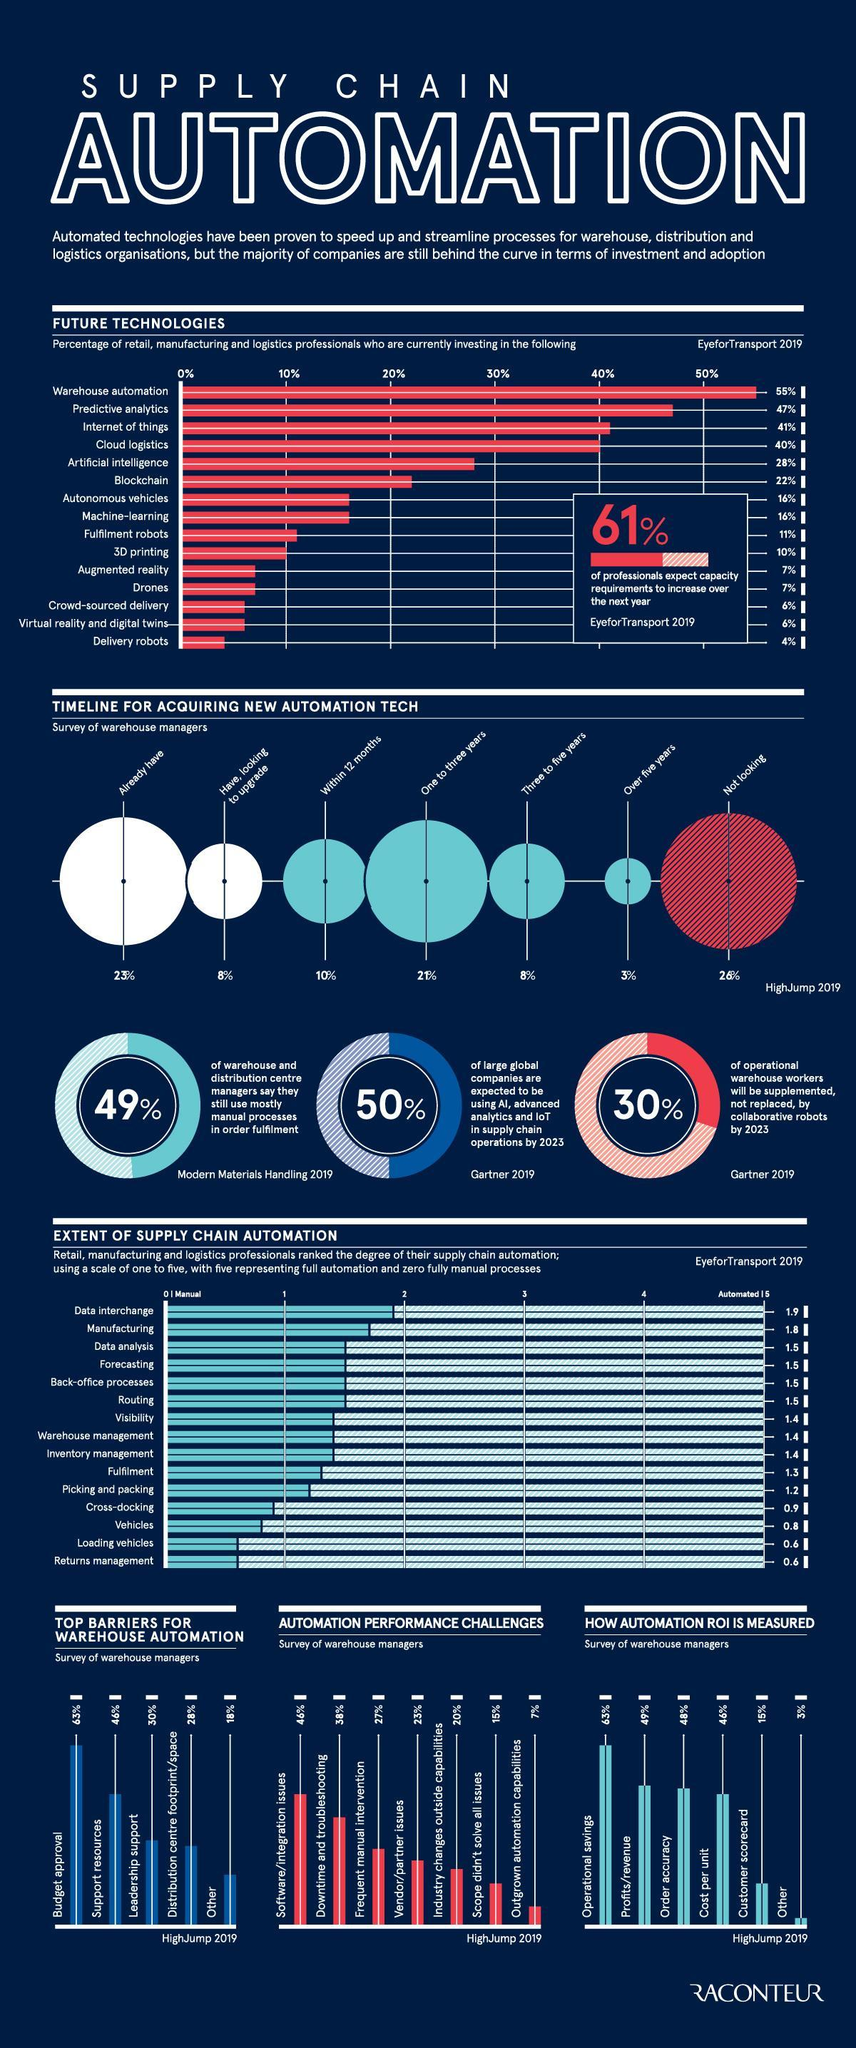What percentage of professionals have no plans to update to automation technologies within 5 years?
Answer the question with a short phrase. 3% Which upcoming technology has the second most position among future technologies? Predictive analytics What percentage of professionals have plans to update to automation technologies within 5 years? 39 How many upcoming technologies have usage ratings more than 40%? 3 Which is the technology that ranked third position among other future technologies? Internet of things Which factor ranks second position when calculating with Automation ROI? Profits/revenue What percentage of professionals are yet to move into latest automation technologies? 77 Which is the third most challenge faced by using Automation tool? Frequent Manual Intervention What percentage of professionals have plans to update to automation technologies? 8% What percentage of companies are not interested to invest in latest Automation technologies? 26% 